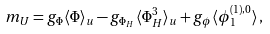Convert formula to latex. <formula><loc_0><loc_0><loc_500><loc_500>m _ { U } = g _ { \Phi } \langle \Phi \rangle _ { u } - g _ { \Phi _ { H } } \langle \Phi _ { H } ^ { 3 } \rangle _ { u } + g _ { \phi } \langle \phi _ { 1 } ^ { ( 1 ) , 0 } \rangle \, ,</formula> 